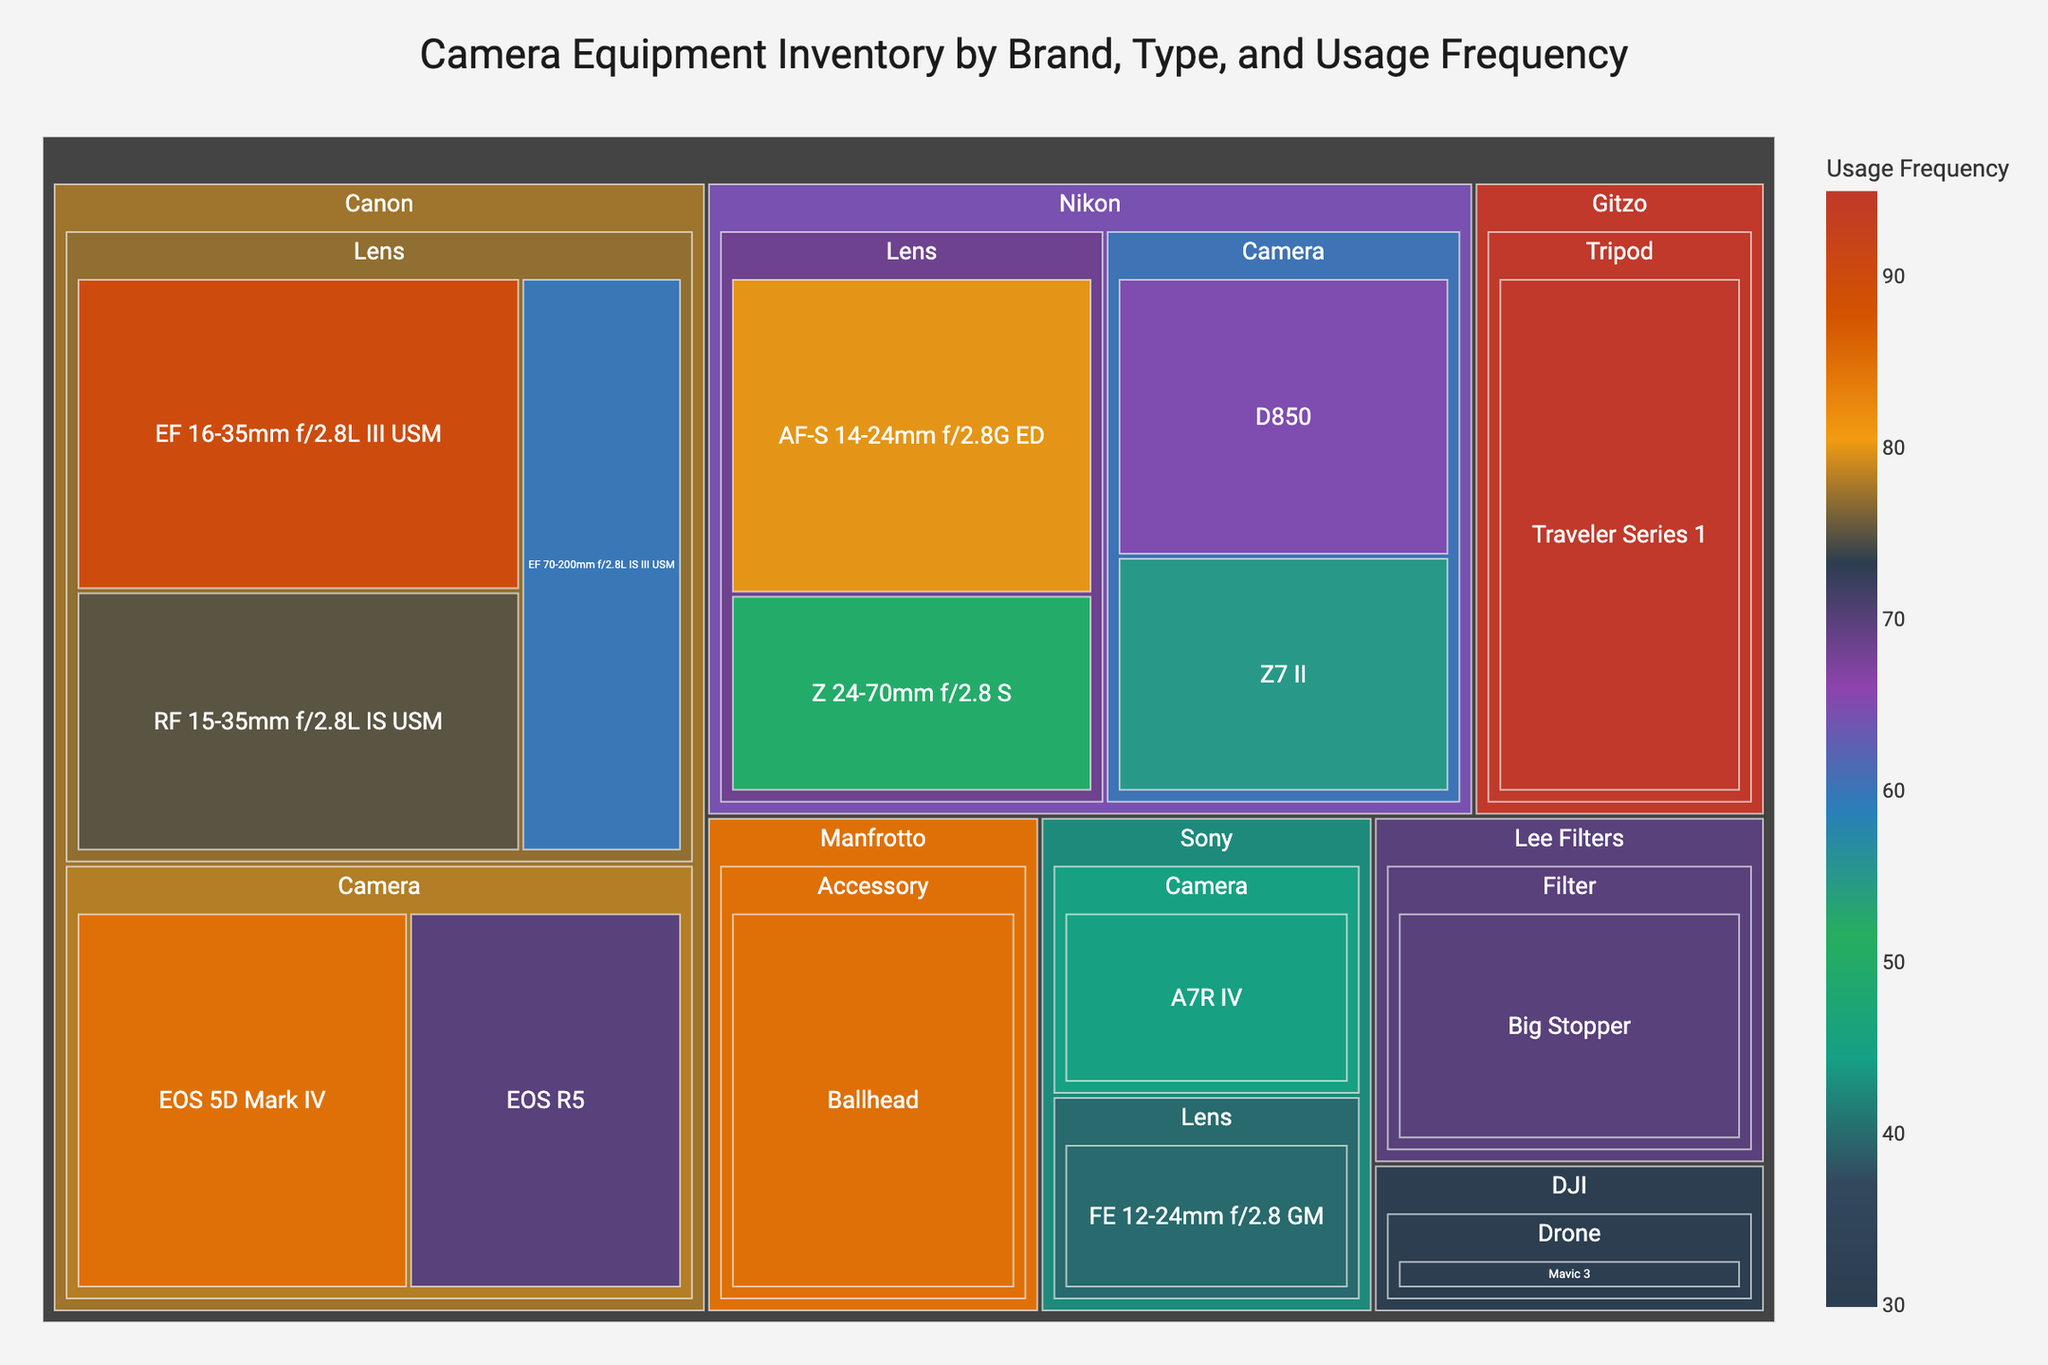What is the title of the treemap? The title is located at the top center of the treemap. It reads "Camera Equipment Inventory by Brand, Type, and Usage Frequency".
Answer: Camera Equipment Inventory by Brand, Type, and Usage Frequency Which brand and type of equipment have the highest usage frequency? The biggest rectangle in the treemap, which corresponds to the highest usage frequency, is for Gitzo's "Traveler Series 1" Tripod with a usage frequency of 95.
Answer: Gitzo Tripod How many camera models from Canon are present in the inventory? By looking at the "Canon" section and counting the camera models under it, we see "EOS 5D Mark IV" and "EOS R5", making it two camera models.
Answer: 2 Which lens from Nikon has the higher usage frequency? By looking at the Nikon section of the treemap, compare the "AF-S 14-24mm f/2.8G ED" and "Z 24-70mm f/2.8 S". The "AF-S 14-24mm f/2.8G ED" has a frequency of 80, while the "Z 24-70mm f/2.8 S" has a frequency of 50.
Answer: AF-S 14-24mm f/2.8G ED What is the total usage frequency of all Canon equipment? Summing up the usage frequencies under Canon: EOS 5D Mark IV (85), EOS R5 (70), EF 16-35mm f/2.8L III USM (90), RF 15-35mm f/2.8L IS USM (75), and EF 70-200mm f/2.8L IS III USM (60). The total is 85 + 70 + 90 + 75 + 60 = 380.
Answer: 380 Which brand has the lowest frequency of any single piece of equipment, and what is it? By comparing all individual equipments, DJI's "Mavic 3" drone has the lowest frequency with a value of 30.
Answer: DJI Drone Compare the usage frequencies of Canon and Sony cameras. Which brand's cameras are used more frequently overall? Summing up usage frequencies of Canon cameras: EOS 5D Mark IV (85) and EOS R5 (70) gives 85 + 70 = 155. For Sony: A7R IV (45). Canon's cameras are used more frequently with a total of 155 vs. 45.
Answer: Canon What is the average usage frequency of lenses from all brands combined? Sum the frequencies of all lenses: EF 16-35mm f/2.8L III USM (90), RF 15-35mm f/2.8L IS USM (75), EF 70-200mm f/2.8L IS III USM (60), AF-S 14-24mm f/2.8G ED (80), Z 24-70mm f/2.8 S (50), FE 12-24mm f/2.8 GM (40). The sum is 90 + 75 + 60 + 80 + 50 + 40 = 395. There are 6 lenses in total. So, the average is 395 / 6 ≈ 65.83.
Answer: 65.83 Which Nikon camera has a lower usage frequency and by how much compared to the other Nikon camera? Compare Nikon D850 (65) and Z7 II (55). The D850 has a higher frequency. The difference is 65 - 55 = 10.
Answer: Z7 II by 10 